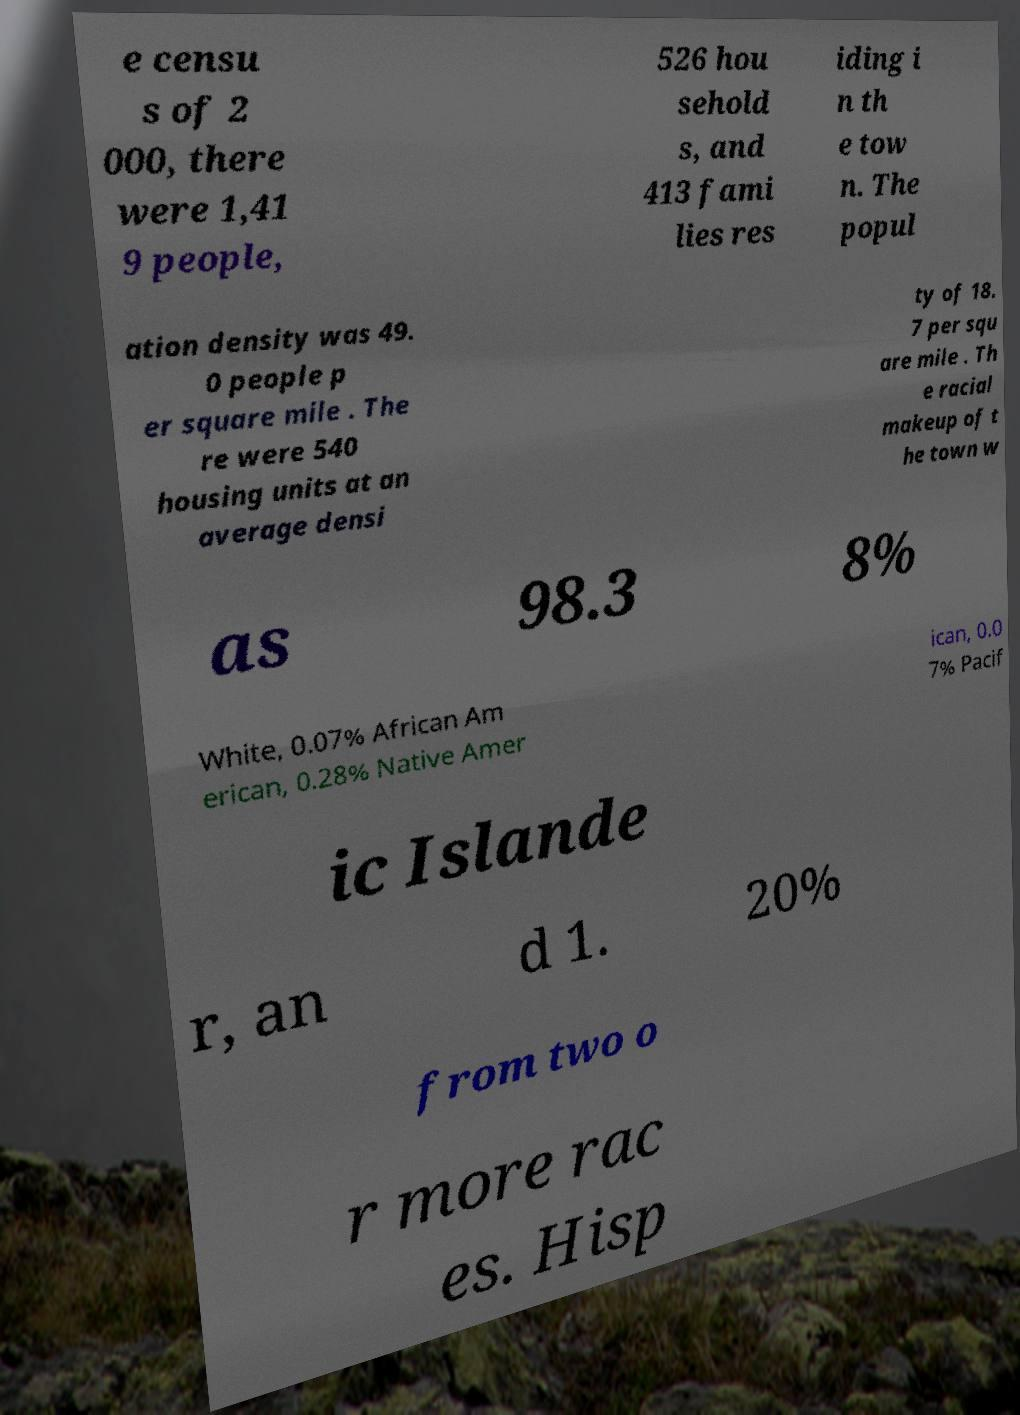Can you accurately transcribe the text from the provided image for me? e censu s of 2 000, there were 1,41 9 people, 526 hou sehold s, and 413 fami lies res iding i n th e tow n. The popul ation density was 49. 0 people p er square mile . The re were 540 housing units at an average densi ty of 18. 7 per squ are mile . Th e racial makeup of t he town w as 98.3 8% White, 0.07% African Am erican, 0.28% Native Amer ican, 0.0 7% Pacif ic Islande r, an d 1. 20% from two o r more rac es. Hisp 